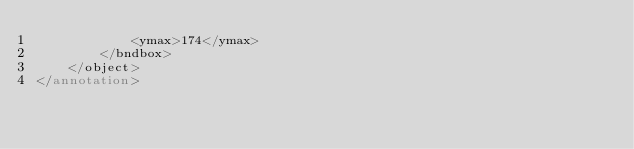<code> <loc_0><loc_0><loc_500><loc_500><_XML_>			<ymax>174</ymax>
		</bndbox>
	</object>
</annotation>
</code> 